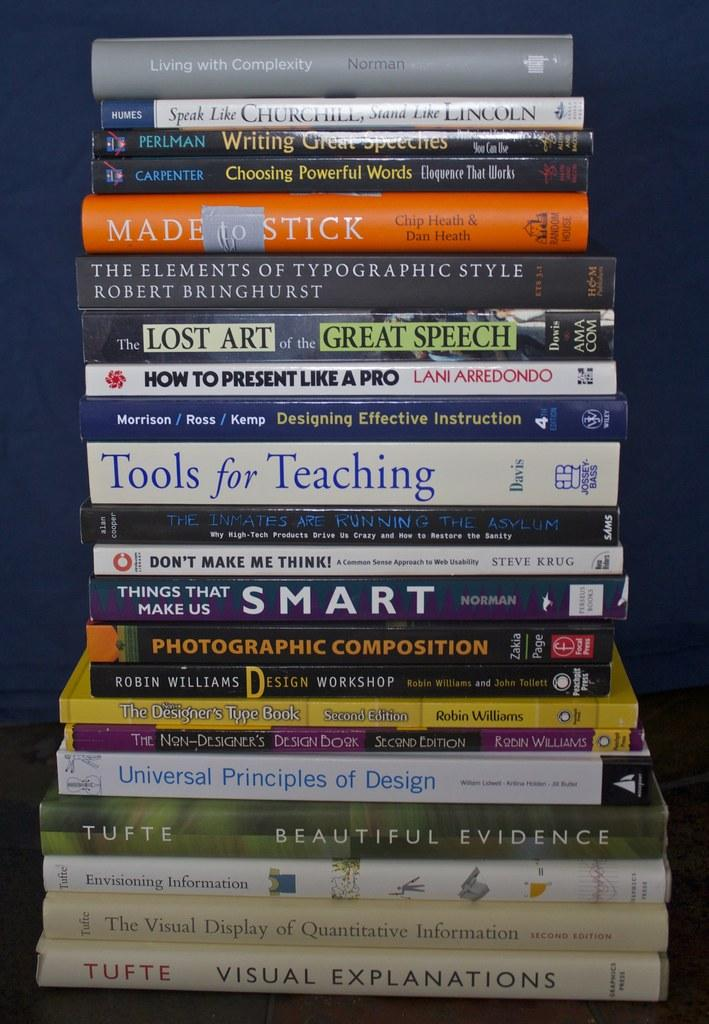<image>
Give a short and clear explanation of the subsequent image. A stack of books about communication sits on a table. 